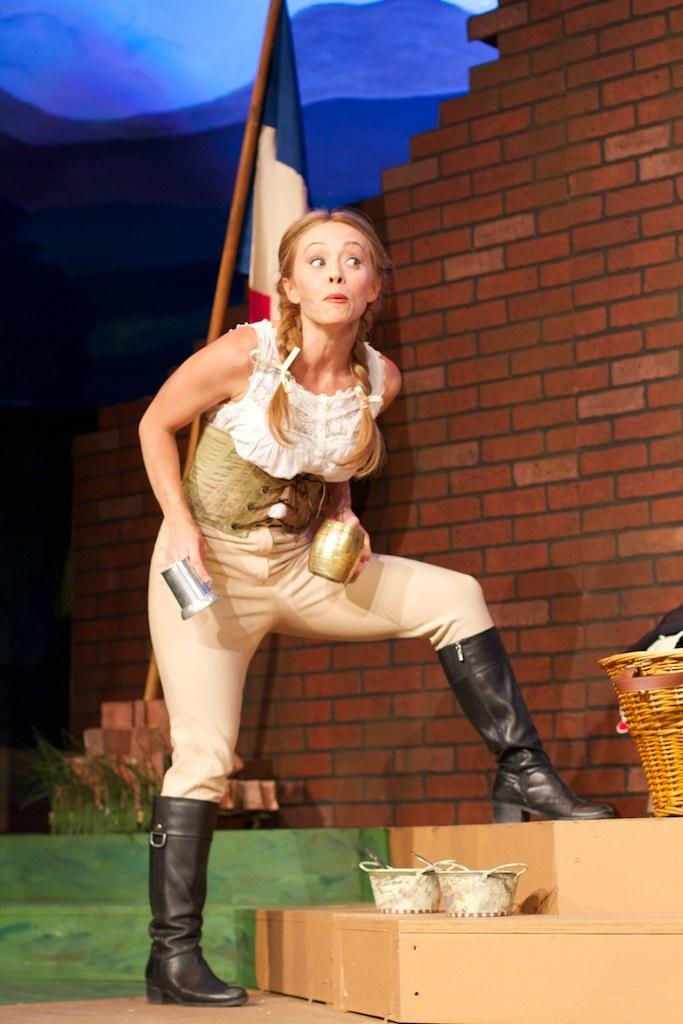What is the woman in the image holding? The woman is holding objects in the image. What can be seen on the stand in the image? There are baskets with objects on a stand. What structure is present in the image? There is a flag pole in the image. What type of material is visible in the image? There are bricks visible in the image. What is the background of the image like? The background of the image is dark. What type of gold jewelry is the woman wearing in the image? There is no gold jewelry visible on the woman in the image. Where is the lunchroom located in the image? There is no mention of a lunchroom in the image; it does not appear to be present. 